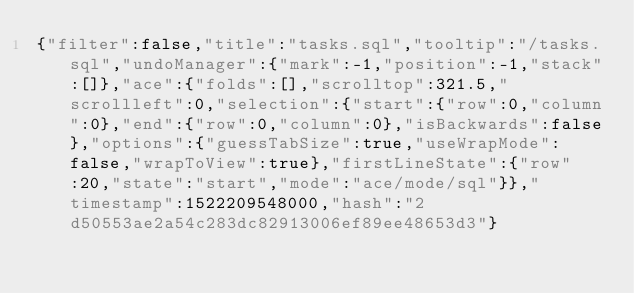<code> <loc_0><loc_0><loc_500><loc_500><_SQL_>{"filter":false,"title":"tasks.sql","tooltip":"/tasks.sql","undoManager":{"mark":-1,"position":-1,"stack":[]},"ace":{"folds":[],"scrolltop":321.5,"scrollleft":0,"selection":{"start":{"row":0,"column":0},"end":{"row":0,"column":0},"isBackwards":false},"options":{"guessTabSize":true,"useWrapMode":false,"wrapToView":true},"firstLineState":{"row":20,"state":"start","mode":"ace/mode/sql"}},"timestamp":1522209548000,"hash":"2d50553ae2a54c283dc82913006ef89ee48653d3"}</code> 